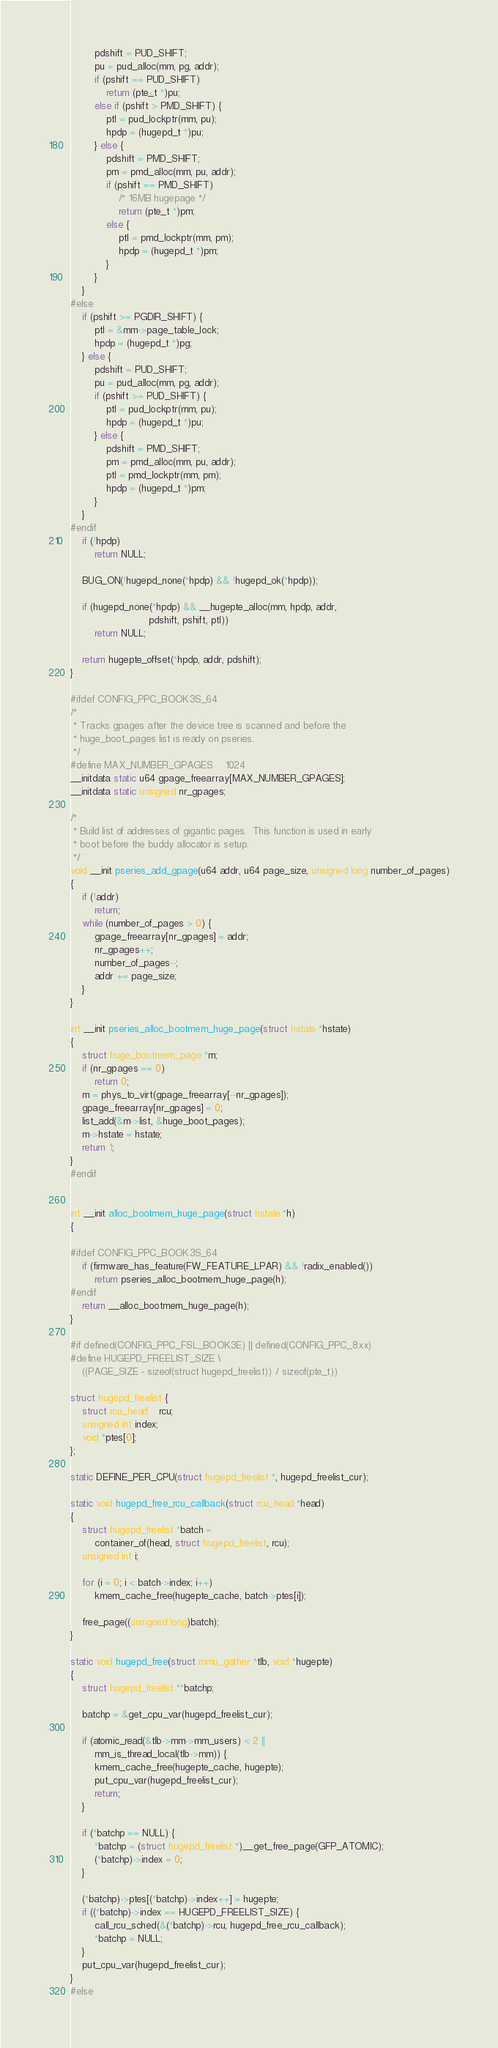Convert code to text. <code><loc_0><loc_0><loc_500><loc_500><_C_>		pdshift = PUD_SHIFT;
		pu = pud_alloc(mm, pg, addr);
		if (pshift == PUD_SHIFT)
			return (pte_t *)pu;
		else if (pshift > PMD_SHIFT) {
			ptl = pud_lockptr(mm, pu);
			hpdp = (hugepd_t *)pu;
		} else {
			pdshift = PMD_SHIFT;
			pm = pmd_alloc(mm, pu, addr);
			if (pshift == PMD_SHIFT)
				/* 16MB hugepage */
				return (pte_t *)pm;
			else {
				ptl = pmd_lockptr(mm, pm);
				hpdp = (hugepd_t *)pm;
			}
		}
	}
#else
	if (pshift >= PGDIR_SHIFT) {
		ptl = &mm->page_table_lock;
		hpdp = (hugepd_t *)pg;
	} else {
		pdshift = PUD_SHIFT;
		pu = pud_alloc(mm, pg, addr);
		if (pshift >= PUD_SHIFT) {
			ptl = pud_lockptr(mm, pu);
			hpdp = (hugepd_t *)pu;
		} else {
			pdshift = PMD_SHIFT;
			pm = pmd_alloc(mm, pu, addr);
			ptl = pmd_lockptr(mm, pm);
			hpdp = (hugepd_t *)pm;
		}
	}
#endif
	if (!hpdp)
		return NULL;

	BUG_ON(!hugepd_none(*hpdp) && !hugepd_ok(*hpdp));

	if (hugepd_none(*hpdp) && __hugepte_alloc(mm, hpdp, addr,
						  pdshift, pshift, ptl))
		return NULL;

	return hugepte_offset(*hpdp, addr, pdshift);
}

#ifdef CONFIG_PPC_BOOK3S_64
/*
 * Tracks gpages after the device tree is scanned and before the
 * huge_boot_pages list is ready on pseries.
 */
#define MAX_NUMBER_GPAGES	1024
__initdata static u64 gpage_freearray[MAX_NUMBER_GPAGES];
__initdata static unsigned nr_gpages;

/*
 * Build list of addresses of gigantic pages.  This function is used in early
 * boot before the buddy allocator is setup.
 */
void __init pseries_add_gpage(u64 addr, u64 page_size, unsigned long number_of_pages)
{
	if (!addr)
		return;
	while (number_of_pages > 0) {
		gpage_freearray[nr_gpages] = addr;
		nr_gpages++;
		number_of_pages--;
		addr += page_size;
	}
}

int __init pseries_alloc_bootmem_huge_page(struct hstate *hstate)
{
	struct huge_bootmem_page *m;
	if (nr_gpages == 0)
		return 0;
	m = phys_to_virt(gpage_freearray[--nr_gpages]);
	gpage_freearray[nr_gpages] = 0;
	list_add(&m->list, &huge_boot_pages);
	m->hstate = hstate;
	return 1;
}
#endif


int __init alloc_bootmem_huge_page(struct hstate *h)
{

#ifdef CONFIG_PPC_BOOK3S_64
	if (firmware_has_feature(FW_FEATURE_LPAR) && !radix_enabled())
		return pseries_alloc_bootmem_huge_page(h);
#endif
	return __alloc_bootmem_huge_page(h);
}

#if defined(CONFIG_PPC_FSL_BOOK3E) || defined(CONFIG_PPC_8xx)
#define HUGEPD_FREELIST_SIZE \
	((PAGE_SIZE - sizeof(struct hugepd_freelist)) / sizeof(pte_t))

struct hugepd_freelist {
	struct rcu_head	rcu;
	unsigned int index;
	void *ptes[0];
};

static DEFINE_PER_CPU(struct hugepd_freelist *, hugepd_freelist_cur);

static void hugepd_free_rcu_callback(struct rcu_head *head)
{
	struct hugepd_freelist *batch =
		container_of(head, struct hugepd_freelist, rcu);
	unsigned int i;

	for (i = 0; i < batch->index; i++)
		kmem_cache_free(hugepte_cache, batch->ptes[i]);

	free_page((unsigned long)batch);
}

static void hugepd_free(struct mmu_gather *tlb, void *hugepte)
{
	struct hugepd_freelist **batchp;

	batchp = &get_cpu_var(hugepd_freelist_cur);

	if (atomic_read(&tlb->mm->mm_users) < 2 ||
	    mm_is_thread_local(tlb->mm)) {
		kmem_cache_free(hugepte_cache, hugepte);
		put_cpu_var(hugepd_freelist_cur);
		return;
	}

	if (*batchp == NULL) {
		*batchp = (struct hugepd_freelist *)__get_free_page(GFP_ATOMIC);
		(*batchp)->index = 0;
	}

	(*batchp)->ptes[(*batchp)->index++] = hugepte;
	if ((*batchp)->index == HUGEPD_FREELIST_SIZE) {
		call_rcu_sched(&(*batchp)->rcu, hugepd_free_rcu_callback);
		*batchp = NULL;
	}
	put_cpu_var(hugepd_freelist_cur);
}
#else</code> 